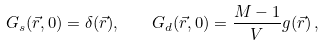<formula> <loc_0><loc_0><loc_500><loc_500>G _ { s } ( \vec { r } , 0 ) = \delta ( \vec { r } ) , \quad G _ { d } ( \vec { r } , 0 ) = \frac { M - 1 } { V } g ( \vec { r } ) \, ,</formula> 